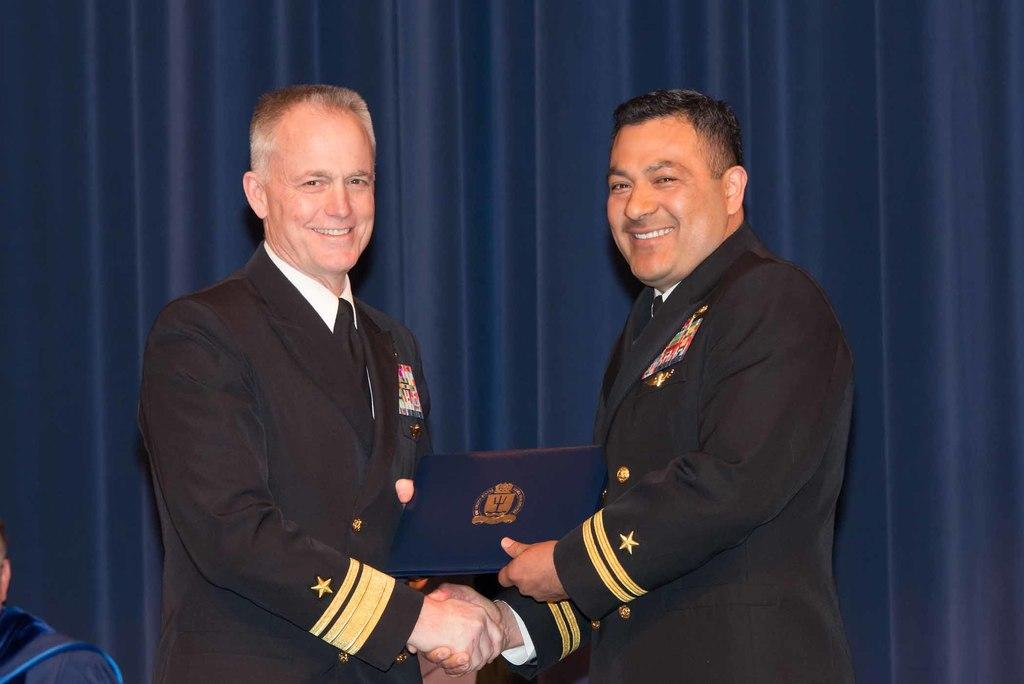How many people are in the image? There are two persons in the image. What are the two persons doing in the image? The two persons are shaking hands and holding a file. What can be seen in the background of the image? There is a blue curtain in the background of the image. What type of horn is visible on the table in the image? There is no horn present in the image; it only features two persons shaking hands and holding a file, with a blue curtain in the background. 